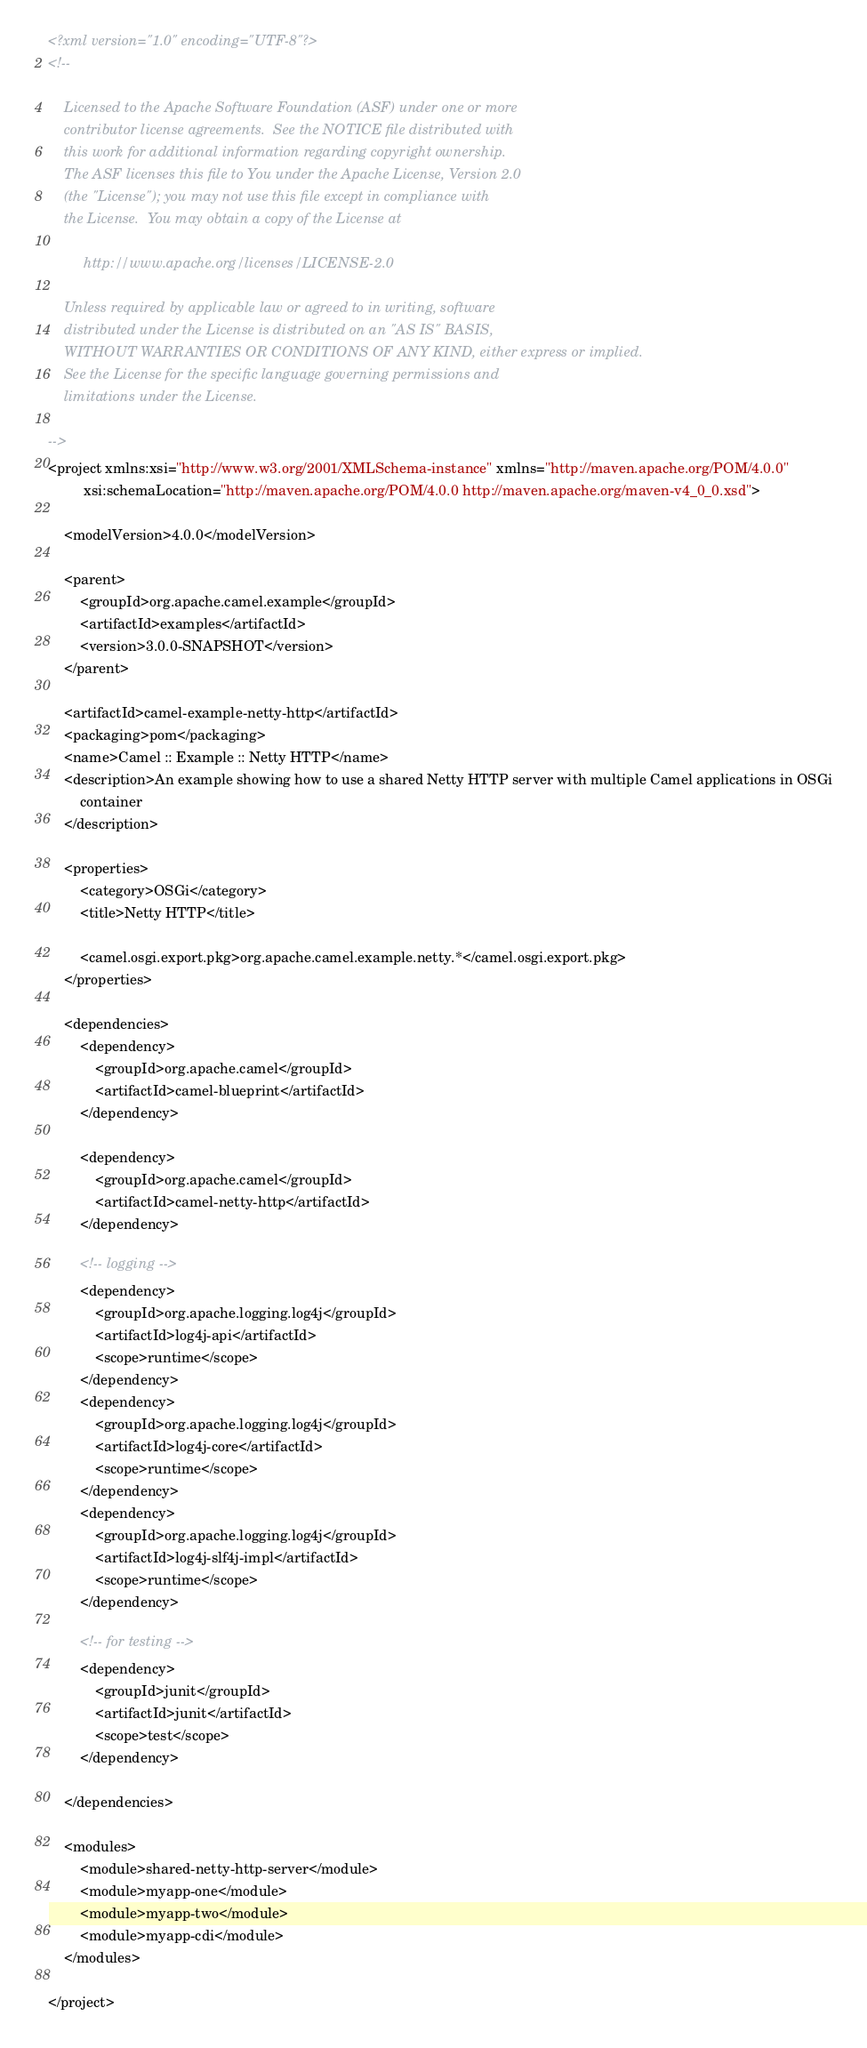Convert code to text. <code><loc_0><loc_0><loc_500><loc_500><_XML_><?xml version="1.0" encoding="UTF-8"?>
<!--

    Licensed to the Apache Software Foundation (ASF) under one or more
    contributor license agreements.  See the NOTICE file distributed with
    this work for additional information regarding copyright ownership.
    The ASF licenses this file to You under the Apache License, Version 2.0
    (the "License"); you may not use this file except in compliance with
    the License.  You may obtain a copy of the License at

         http://www.apache.org/licenses/LICENSE-2.0

    Unless required by applicable law or agreed to in writing, software
    distributed under the License is distributed on an "AS IS" BASIS,
    WITHOUT WARRANTIES OR CONDITIONS OF ANY KIND, either express or implied.
    See the License for the specific language governing permissions and
    limitations under the License.

-->
<project xmlns:xsi="http://www.w3.org/2001/XMLSchema-instance" xmlns="http://maven.apache.org/POM/4.0.0"
         xsi:schemaLocation="http://maven.apache.org/POM/4.0.0 http://maven.apache.org/maven-v4_0_0.xsd">

    <modelVersion>4.0.0</modelVersion>

    <parent>
        <groupId>org.apache.camel.example</groupId>
        <artifactId>examples</artifactId>
        <version>3.0.0-SNAPSHOT</version>
    </parent>

    <artifactId>camel-example-netty-http</artifactId>
    <packaging>pom</packaging>
    <name>Camel :: Example :: Netty HTTP</name>
    <description>An example showing how to use a shared Netty HTTP server with multiple Camel applications in OSGi
        container
    </description>

    <properties>
        <category>OSGi</category>
        <title>Netty HTTP</title>

        <camel.osgi.export.pkg>org.apache.camel.example.netty.*</camel.osgi.export.pkg>
    </properties>

    <dependencies>
        <dependency>
            <groupId>org.apache.camel</groupId>
            <artifactId>camel-blueprint</artifactId>
        </dependency>

        <dependency>
            <groupId>org.apache.camel</groupId>
            <artifactId>camel-netty-http</artifactId>
        </dependency>

        <!-- logging -->
        <dependency>
            <groupId>org.apache.logging.log4j</groupId>
            <artifactId>log4j-api</artifactId>
            <scope>runtime</scope>
        </dependency>
        <dependency>
            <groupId>org.apache.logging.log4j</groupId>
            <artifactId>log4j-core</artifactId>
            <scope>runtime</scope>
        </dependency>
        <dependency>
            <groupId>org.apache.logging.log4j</groupId>
            <artifactId>log4j-slf4j-impl</artifactId>
            <scope>runtime</scope>
        </dependency>

        <!-- for testing -->
        <dependency>
            <groupId>junit</groupId>
            <artifactId>junit</artifactId>
            <scope>test</scope>
        </dependency>

    </dependencies>

    <modules>
        <module>shared-netty-http-server</module>
        <module>myapp-one</module>
        <module>myapp-two</module>
        <module>myapp-cdi</module>
    </modules>

</project>
</code> 